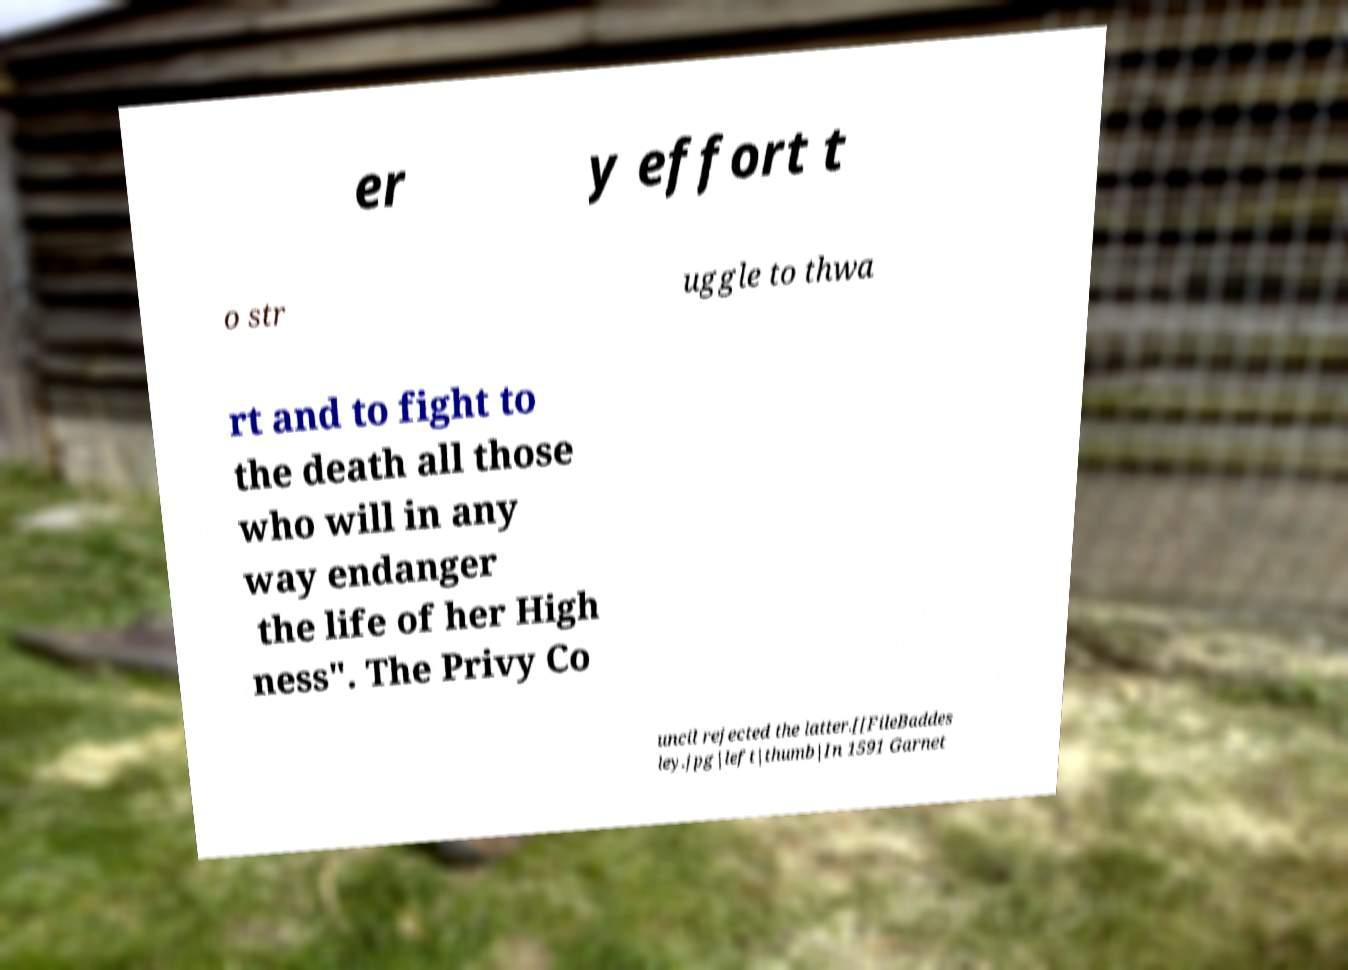Please identify and transcribe the text found in this image. er y effort t o str uggle to thwa rt and to fight to the death all those who will in any way endanger the life of her High ness". The Privy Co uncil rejected the latter.[[FileBaddes ley.jpg|left|thumb|In 1591 Garnet 